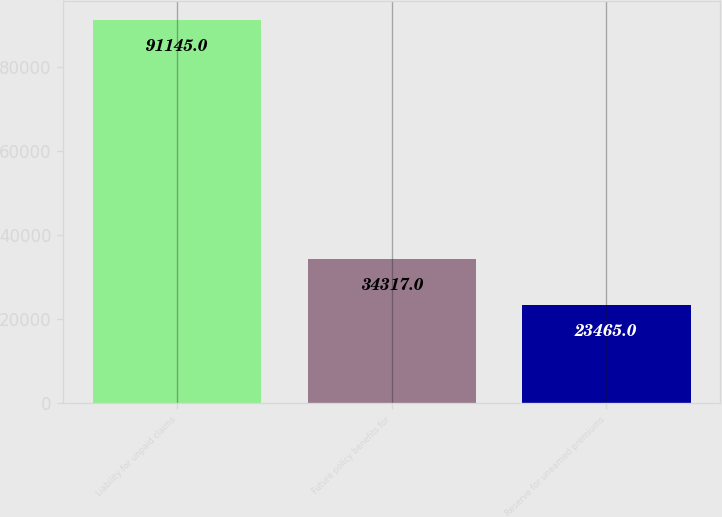<chart> <loc_0><loc_0><loc_500><loc_500><bar_chart><fcel>Liability for unpaid claims<fcel>Future policy benefits for<fcel>Reserve for unearned premiums<nl><fcel>91145<fcel>34317<fcel>23465<nl></chart> 